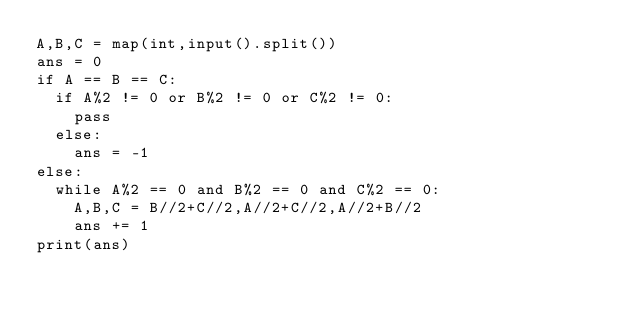<code> <loc_0><loc_0><loc_500><loc_500><_Python_>A,B,C = map(int,input().split())
ans = 0
if A == B == C:
  if A%2 != 0 or B%2 != 0 or C%2 != 0:
    pass
  else:
    ans = -1
else:
  while A%2 == 0 and B%2 == 0 and C%2 == 0:
    A,B,C = B//2+C//2,A//2+C//2,A//2+B//2
    ans += 1
print(ans)</code> 